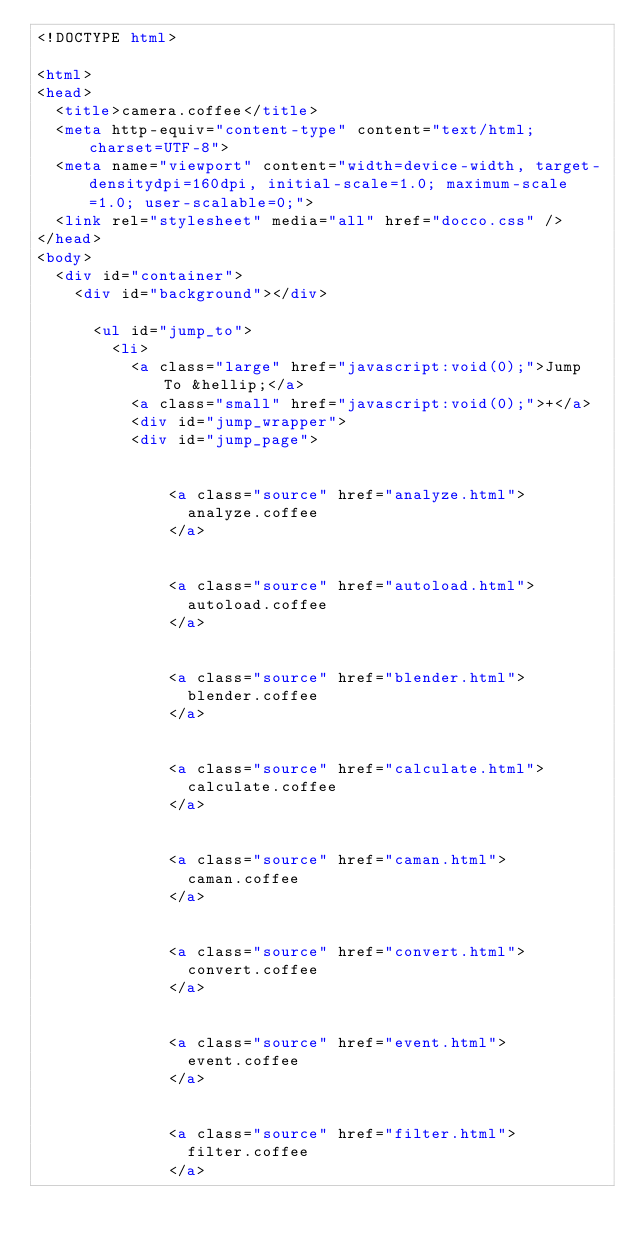Convert code to text. <code><loc_0><loc_0><loc_500><loc_500><_HTML_><!DOCTYPE html>

<html>
<head>
  <title>camera.coffee</title>
  <meta http-equiv="content-type" content="text/html; charset=UTF-8">
  <meta name="viewport" content="width=device-width, target-densitydpi=160dpi, initial-scale=1.0; maximum-scale=1.0; user-scalable=0;">
  <link rel="stylesheet" media="all" href="docco.css" />
</head>
<body>
  <div id="container">
    <div id="background"></div>
    
      <ul id="jump_to">
        <li>
          <a class="large" href="javascript:void(0);">Jump To &hellip;</a>
          <a class="small" href="javascript:void(0);">+</a>
          <div id="jump_wrapper">
          <div id="jump_page">
            
              
              <a class="source" href="analyze.html">
                analyze.coffee
              </a>
            
              
              <a class="source" href="autoload.html">
                autoload.coffee
              </a>
            
              
              <a class="source" href="blender.html">
                blender.coffee
              </a>
            
              
              <a class="source" href="calculate.html">
                calculate.coffee
              </a>
            
              
              <a class="source" href="caman.html">
                caman.coffee
              </a>
            
              
              <a class="source" href="convert.html">
                convert.coffee
              </a>
            
              
              <a class="source" href="event.html">
                event.coffee
              </a>
            
              
              <a class="source" href="filter.html">
                filter.coffee
              </a>
            
              </code> 